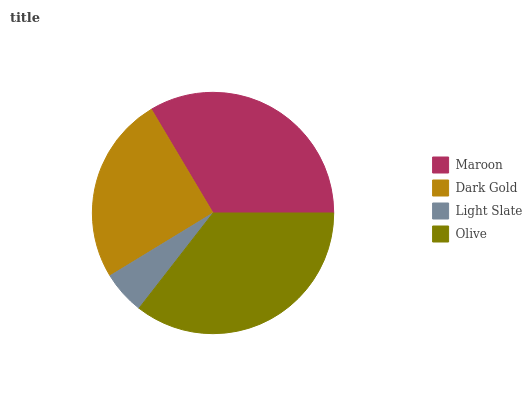Is Light Slate the minimum?
Answer yes or no. Yes. Is Olive the maximum?
Answer yes or no. Yes. Is Dark Gold the minimum?
Answer yes or no. No. Is Dark Gold the maximum?
Answer yes or no. No. Is Maroon greater than Dark Gold?
Answer yes or no. Yes. Is Dark Gold less than Maroon?
Answer yes or no. Yes. Is Dark Gold greater than Maroon?
Answer yes or no. No. Is Maroon less than Dark Gold?
Answer yes or no. No. Is Maroon the high median?
Answer yes or no. Yes. Is Dark Gold the low median?
Answer yes or no. Yes. Is Olive the high median?
Answer yes or no. No. Is Olive the low median?
Answer yes or no. No. 